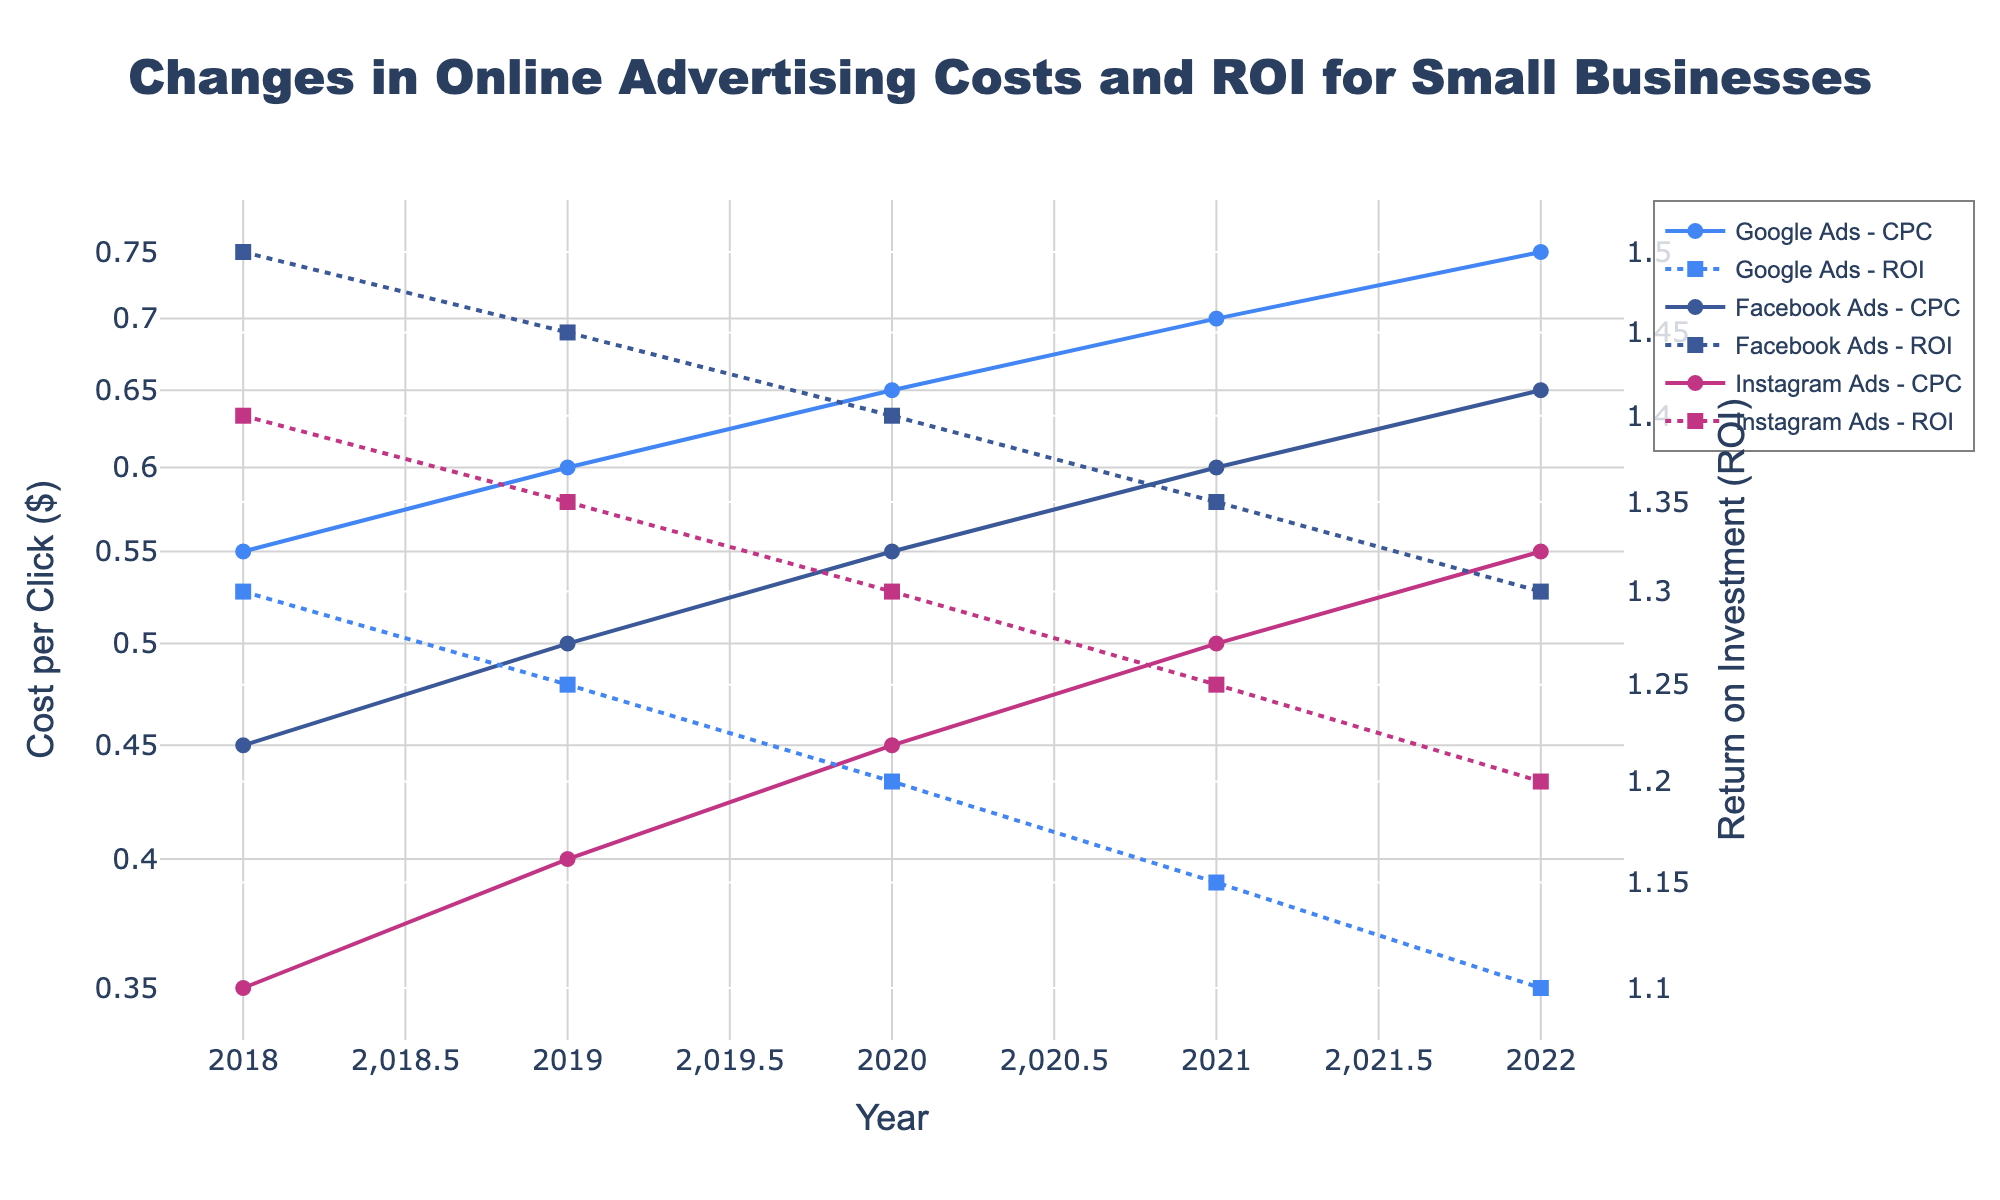What's the title of the plot? The title is prominently shown at the top of the plot and reads 'Changes in Online Advertising Costs and ROI for Small Businesses'.
Answer: Changes in Online Advertising Costs and ROI for Small Businesses What years does the plot cover? The x-axis represents the years, and the plot covers data from 2018 to 2022.
Answer: 2018 to 2022 Which platform had the lowest cost per click (CPC) in 2020? The line representing the CPC for each platform is indicated by solid lines with markers. By observing the year 2020 along the x-axis, the platform with the lowest CPC is Instagram Ads.
Answer: Instagram Ads How did the ROI for Google Ads change from 2018 to 2022? To understand this, trace the line for ROI of Google Ads (indicated by dotted lines and markers) from 2018 to 2022. The ROI for Google Ads decreases consistently from approximately 1.3 in 2018 to 1.1 in 2022.
Answer: Decreased Which advertising platform had the highest cost per click (CPC) in 2022? By observing the year 2022 on the x-axis and identifying the highest value among the CPC (solid lines), it can be seen that Google Ads had the highest CPC.
Answer: Google Ads Compare the ROI of Facebook Ads to Instagram Ads in 2021. Which had a higher ROI? Trace the dotted lines representing ROI for both Facebook Ads and Instagram Ads to the year 2021. Facebook Ads had an ROI of approximately 1.35 while Instagram Ads had an ROI of 1.25, indicating Facebook Ads had a higher ROI.
Answer: Facebook Ads What is the overall trend for the cost per click (CPC) for all platforms from 2018 to 2022? By following the solid lines for CPC across the years 2018 to 2022 for all platforms, the trend indicates that the CPC has increased for Google Ads, Facebook Ads, and Instagram Ads.
Answer: Increased Which platform showed the smallest change in ROI from 2018 to 2022? By examining the dotted lines for ROI across these years, Instagram Ads shows the most consistent values, ranging from 1.4 in 2018 to 1.2 in 2022, indicating the smallest change.
Answer: Instagram Ads What's the difference in CPC between Google Ads and Facebook Ads in 2019? To find the difference, note the CPC values for Google Ads (0.6) and Facebook Ads (0.5) in 2019. The difference is 0.6 - 0.5.
Answer: 0.1 